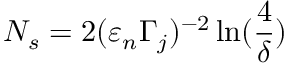Convert formula to latex. <formula><loc_0><loc_0><loc_500><loc_500>N _ { s } = 2 ( \varepsilon _ { n } \Gamma _ { j } ) ^ { - 2 } \ln ( \frac { 4 } { \delta } )</formula> 